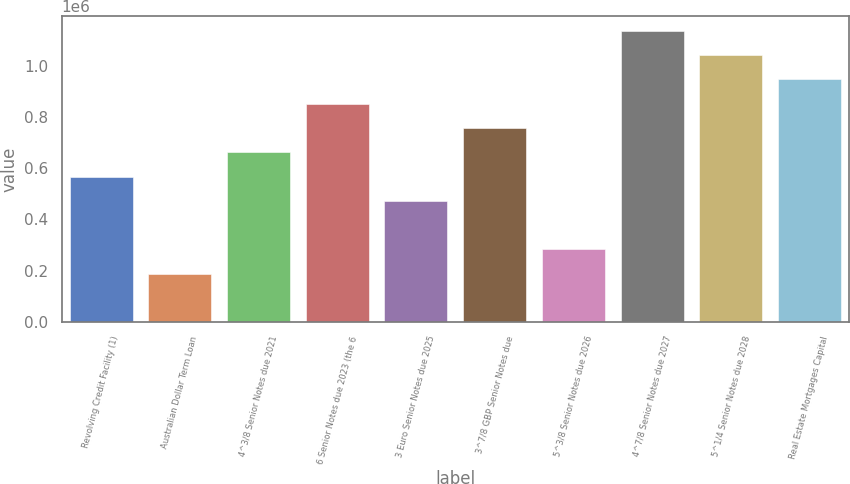<chart> <loc_0><loc_0><loc_500><loc_500><bar_chart><fcel>Revolving Credit Facility (1)<fcel>Australian Dollar Term Loan<fcel>4^3/8 Senior Notes due 2021<fcel>6 Senior Notes due 2023 (the 6<fcel>3 Euro Senior Notes due 2025<fcel>3^7/8 GBP Senior Notes due<fcel>5^3/8 Senior Notes due 2026<fcel>4^7/8 Senior Notes due 2027<fcel>5^1/4 Senior Notes due 2028<fcel>Real Estate Mortgages Capital<nl><fcel>567504<fcel>187504<fcel>662504<fcel>852504<fcel>472504<fcel>757504<fcel>282504<fcel>1.1375e+06<fcel>1.0425e+06<fcel>947504<nl></chart> 